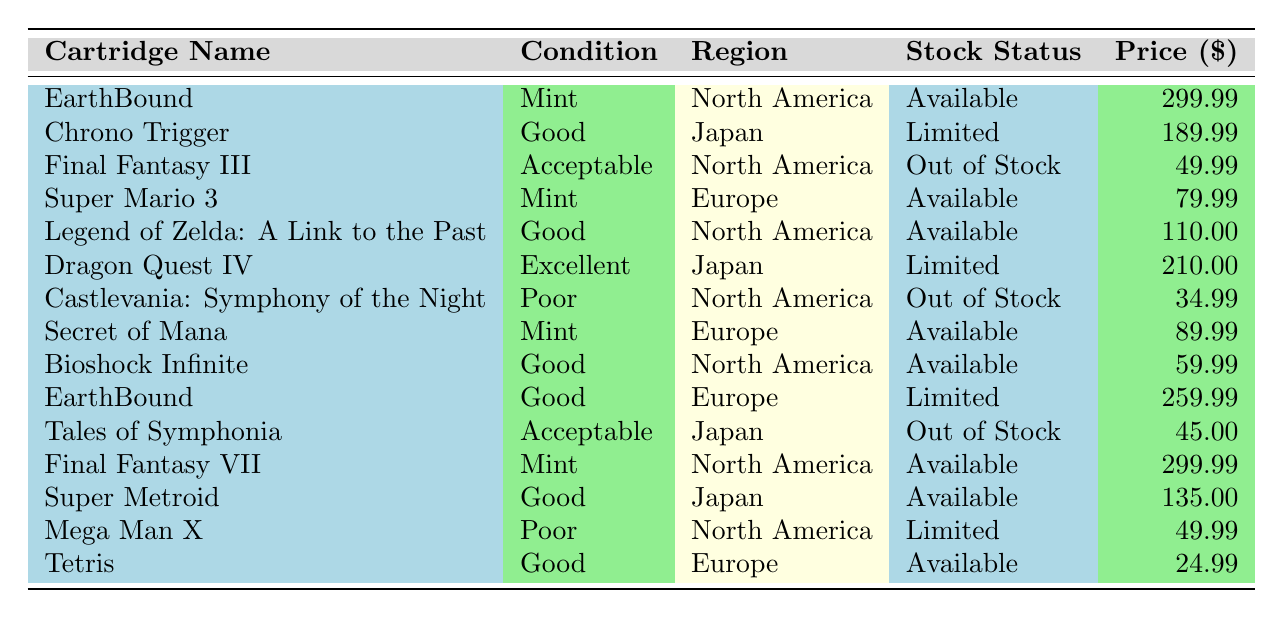What is the price of "Final Fantasy VII"? The price of "Final Fantasy VII" can be found in the table by looking at the row corresponding to this cartridge name. It is listed under the "Price" column. The price is 299.99.
Answer: 299.99 How many cartridges are available in "Mint" condition? To find the number of cartridges in "Mint" condition, I will look through the "Condition" column and count the occurrences of "Mint". There are three entries: "EarthBound", "Super Mario 3", and "Secret of Mana".
Answer: 3 Is "Dragon Quest IV" in stock? To determine if "Dragon Quest IV" is in stock, I can check the "Stock Status" column for the row where the "Cartridge Name" is "Dragon Quest IV". The stock status is listed as "Limited", which indicates it is not fully in stock but some are available.
Answer: No What is the average price of cartridges in "Good" condition? First, I will identify all cartridges that are in "Good" condition and note their prices. The cartridges in "Good" condition are "Chrono Trigger" (189.99), "Legend of Zelda: A Link to the Past" (110.00), "Bioshock Infinite" (59.99), "Super Metroid" (135.00), and "Tetris" (24.99). Next, I will sum these prices: 189.99 + 110.00 + 59.99 + 135.00 + 24.99 = 620.97. Finally, I will divide this total by the number of "Good" condition cartridges, which is 5, giving me an average of 620.97 / 5 = 124.194. Rounding this yields approximately 124.19.
Answer: 124.19 Are there any "Acceptable" condition cartridges that are currently available? I will check the table for cartridges with a "Condition" of "Acceptable" and look at their "Stock Status". The "Acceptable" cartridges are "Final Fantasy III" (Out of Stock) and "Tales of Symphonia" (Out of Stock). Since both are not available, the answer is no.
Answer: No What is the total number of cartridges listed in the North America region? To find this, I will go through the "Region" column and count how many times "North America" appears. The cartridges in this region are: "EarthBound", "Final Fantasy III", "Legend of Zelda: A Link to the Past", "Castlevania: Symphony of the Night", "Bioshock Infinite", "Final Fantasy VII", and "Mega Man X". In total, there are 7 cartridges from North America.
Answer: 7 Which cartridge has the highest price, and what is that price? I will examine the "Price" column to identify the highest value. "EarthBound" (Mint, North America) and "Final Fantasy VII" (Mint, North America) both have a price of 299.99, which is the highest price listed in the table.
Answer: EarthBound and Final Fantasy VII, 299.99 